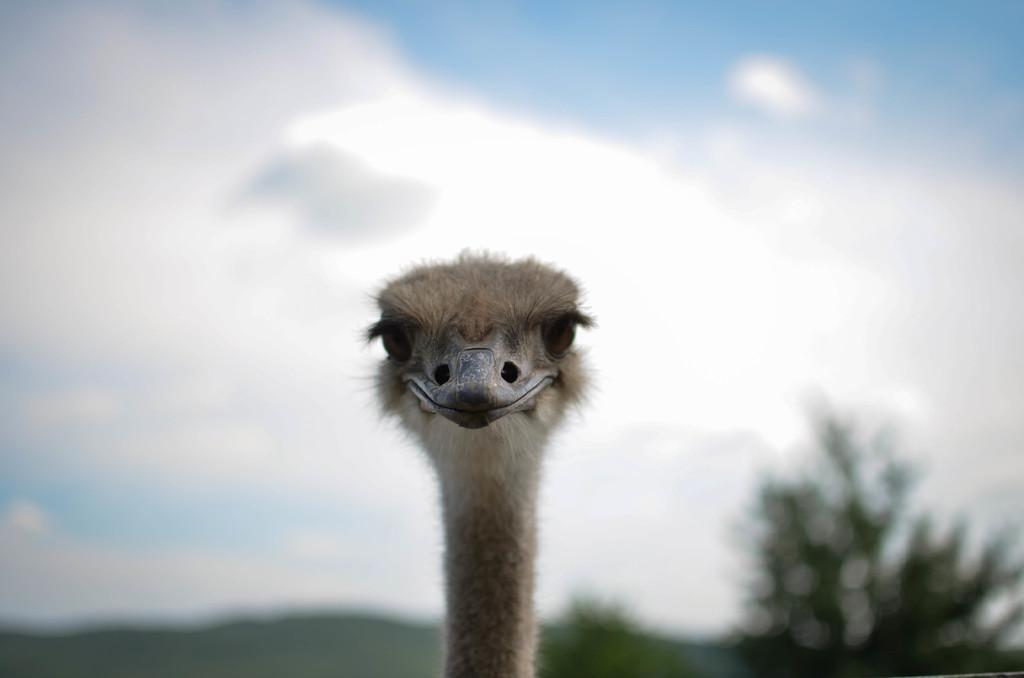Describe this image in one or two sentences. In this image in the front there is an animal. In the background there are trees and the sky is cloudy. 